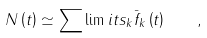<formula> <loc_0><loc_0><loc_500><loc_500>N \left ( t \right ) \simeq \sum \lim i t s _ { k } \bar { f } _ { k } \left ( t \right ) \quad ,</formula> 